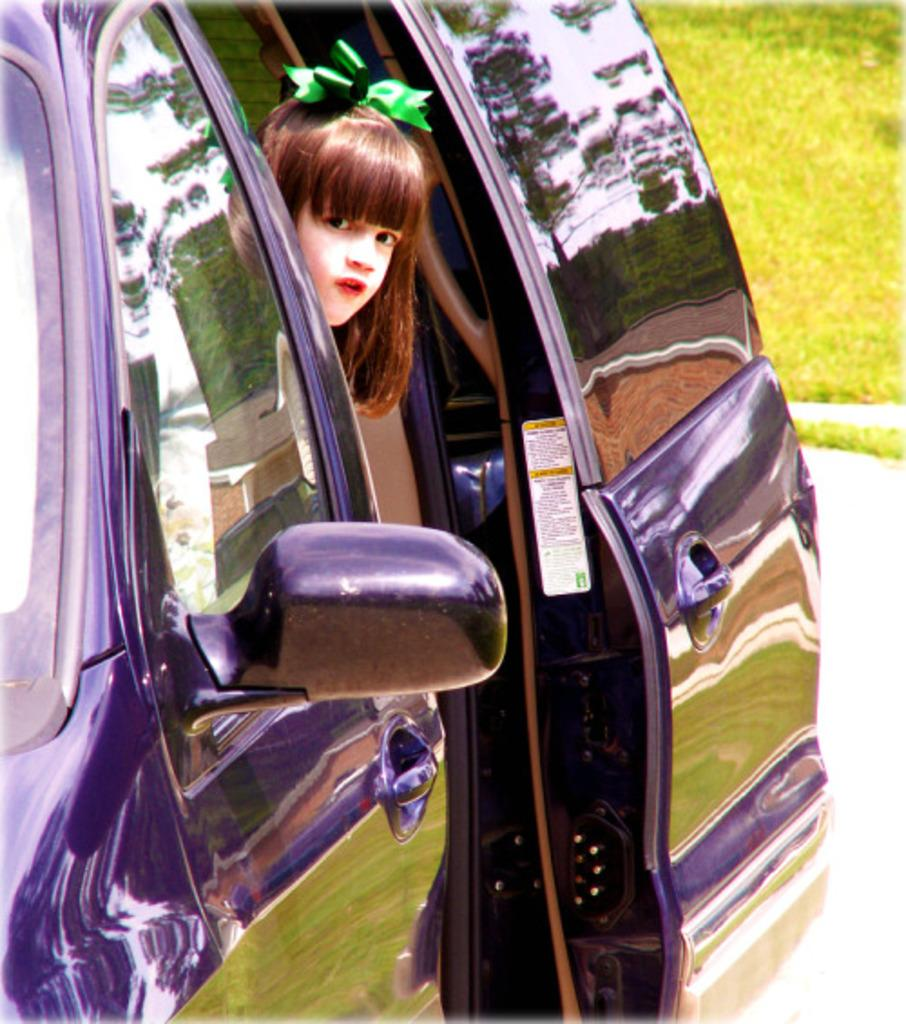What is the main subject of the image? The main subject of the image is a kid. What is the kid doing in the image? The kid is sitting in a car. What is the color of the car in the image? The car is blue in color. What type of shame does the farmer feel in the image? There is no farmer present in the image, and therefore no such emotion can be observed. 